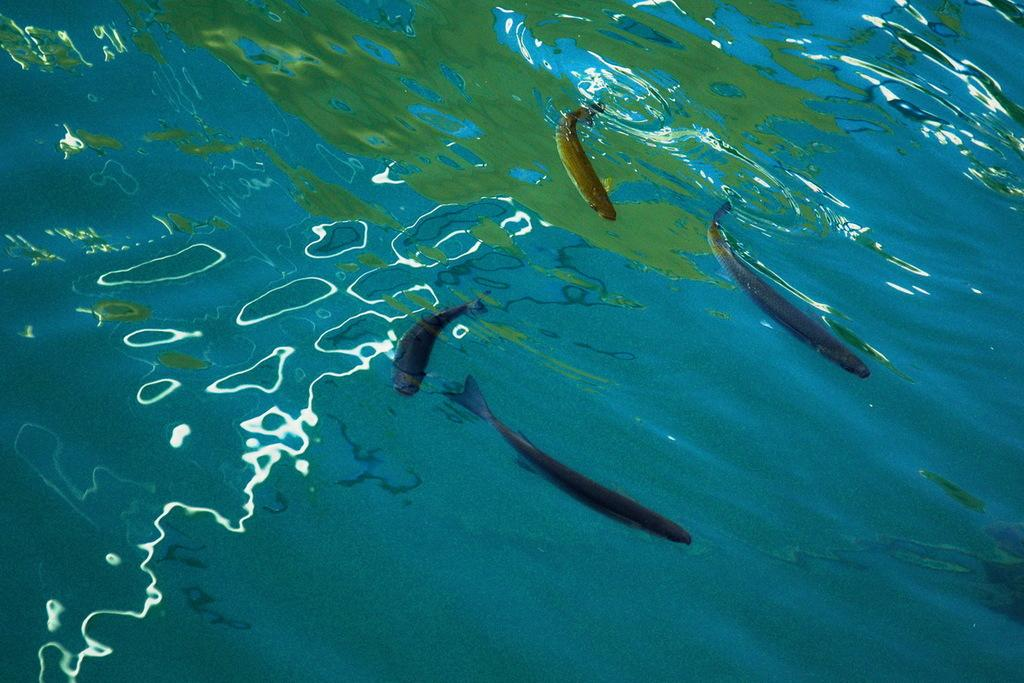What is visible in the image? Water is visible in the image. What can be found in the water? There are fishes in the water. What type of lumber is being transported by the coach in the image? There is no coach or lumber present in the image; it features water with fishes. How many rats can be seen swimming alongside the fishes in the image? There are no rats present in the image; it only features fishes in the water. 